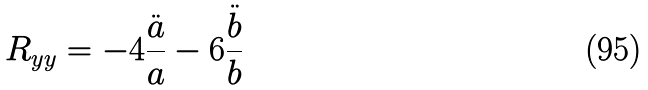Convert formula to latex. <formula><loc_0><loc_0><loc_500><loc_500>R _ { y y } = - 4 \frac { \ddot { a } } { a } - 6 \frac { \ddot { b } } { b }</formula> 